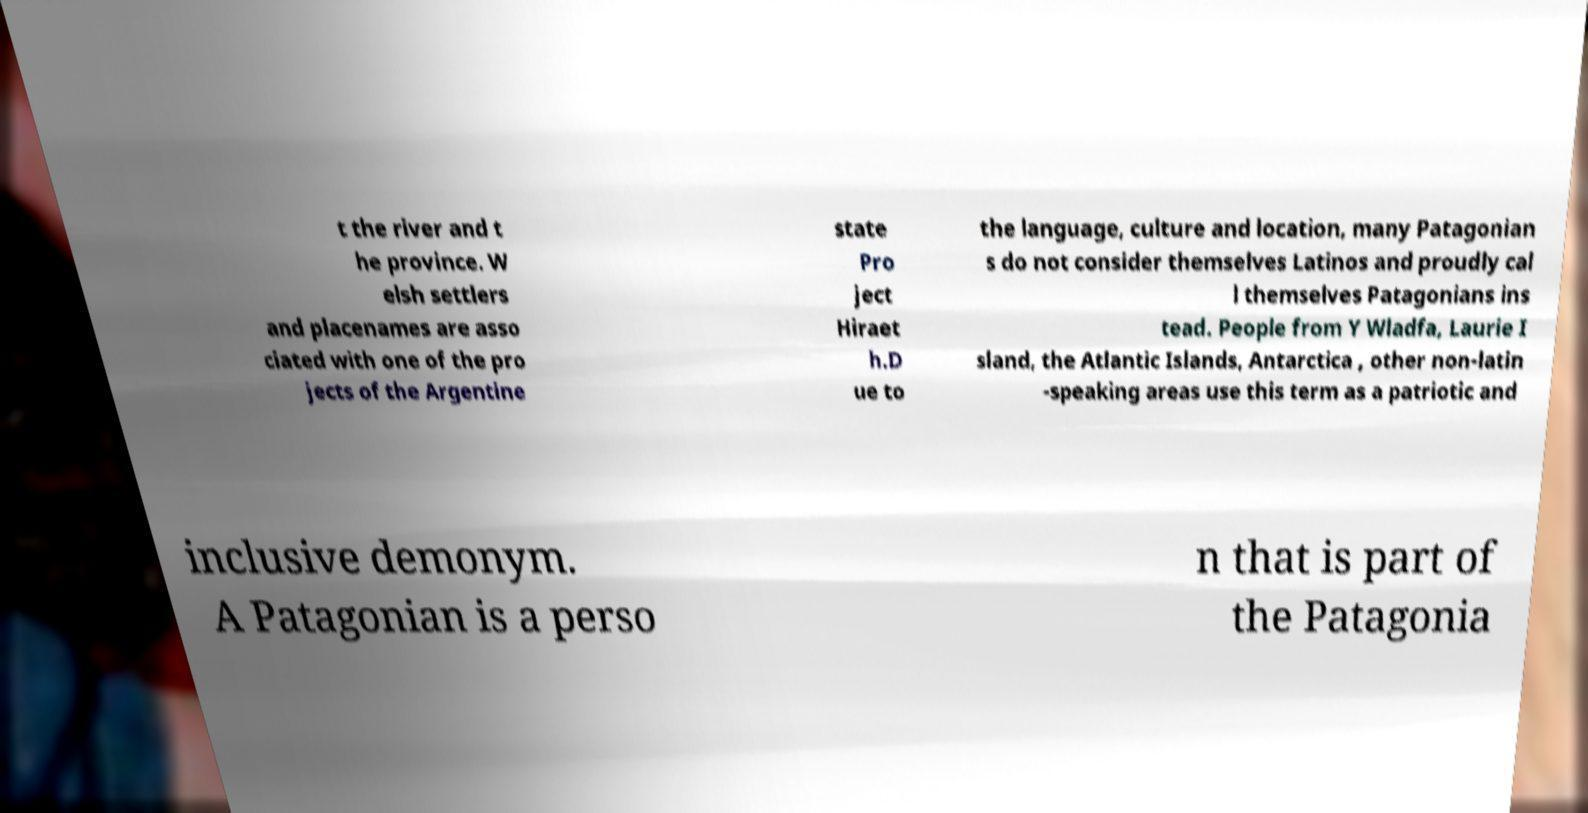Could you assist in decoding the text presented in this image and type it out clearly? t the river and t he province. W elsh settlers and placenames are asso ciated with one of the pro jects of the Argentine state Pro ject Hiraet h.D ue to the language, culture and location, many Patagonian s do not consider themselves Latinos and proudly cal l themselves Patagonians ins tead. People from Y Wladfa, Laurie I sland, the Atlantic Islands, Antarctica , other non-latin -speaking areas use this term as a patriotic and inclusive demonym. A Patagonian is a perso n that is part of the Patagonia 